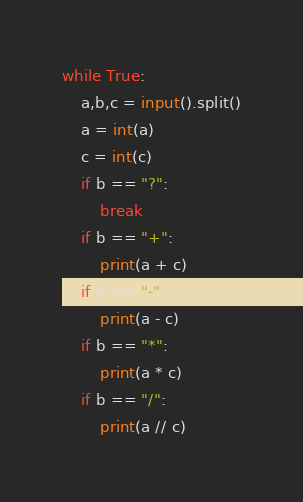Convert code to text. <code><loc_0><loc_0><loc_500><loc_500><_Python_>while True:
	a,b,c = input().split()
	a = int(a)
	c = int(c)
	if b == "?":
		break
	if b == "+":
		print(a + c)
	if b == "-":
		print(a - c)
	if b == "*":
		print(a * c)
	if b == "/":
		print(a // c)
</code> 